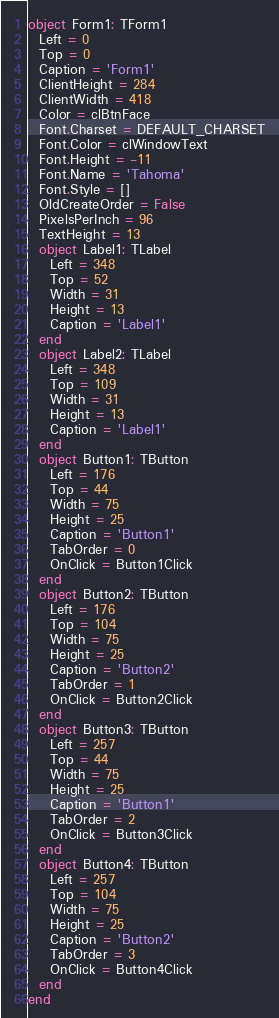Convert code to text. <code><loc_0><loc_0><loc_500><loc_500><_Pascal_>object Form1: TForm1
  Left = 0
  Top = 0
  Caption = 'Form1'
  ClientHeight = 284
  ClientWidth = 418
  Color = clBtnFace
  Font.Charset = DEFAULT_CHARSET
  Font.Color = clWindowText
  Font.Height = -11
  Font.Name = 'Tahoma'
  Font.Style = []
  OldCreateOrder = False
  PixelsPerInch = 96
  TextHeight = 13
  object Label1: TLabel
    Left = 348
    Top = 52
    Width = 31
    Height = 13
    Caption = 'Label1'
  end
  object Label2: TLabel
    Left = 348
    Top = 109
    Width = 31
    Height = 13
    Caption = 'Label1'
  end
  object Button1: TButton
    Left = 176
    Top = 44
    Width = 75
    Height = 25
    Caption = 'Button1'
    TabOrder = 0
    OnClick = Button1Click
  end
  object Button2: TButton
    Left = 176
    Top = 104
    Width = 75
    Height = 25
    Caption = 'Button2'
    TabOrder = 1
    OnClick = Button2Click
  end
  object Button3: TButton
    Left = 257
    Top = 44
    Width = 75
    Height = 25
    Caption = 'Button1'
    TabOrder = 2
    OnClick = Button3Click
  end
  object Button4: TButton
    Left = 257
    Top = 104
    Width = 75
    Height = 25
    Caption = 'Button2'
    TabOrder = 3
    OnClick = Button4Click
  end
end
</code> 